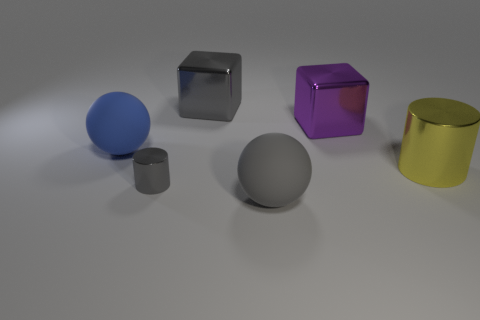The other large rubber thing that is the same shape as the large gray matte object is what color?
Offer a terse response. Blue. There is a matte object in front of the blue object; is it the same size as the small gray object?
Provide a succinct answer. No. There is a gray thing to the left of the large gray object behind the purple metal block; how big is it?
Provide a succinct answer. Small. Is the material of the big yellow thing the same as the big gray ball that is to the left of the large purple cube?
Offer a terse response. No. Is the number of purple things in front of the purple object less than the number of blue things to the left of the blue ball?
Give a very brief answer. No. There is a big cylinder that is made of the same material as the tiny gray object; what color is it?
Offer a terse response. Yellow. Is there a tiny cylinder behind the matte ball that is on the right side of the blue matte ball?
Ensure brevity in your answer.  Yes. There is another shiny cube that is the same size as the gray metallic cube; what is its color?
Offer a terse response. Purple. What number of things are shiny blocks or large cyan metal spheres?
Your answer should be compact. 2. How big is the metal cube to the left of the large rubber ball that is right of the rubber object that is behind the yellow thing?
Ensure brevity in your answer.  Large. 